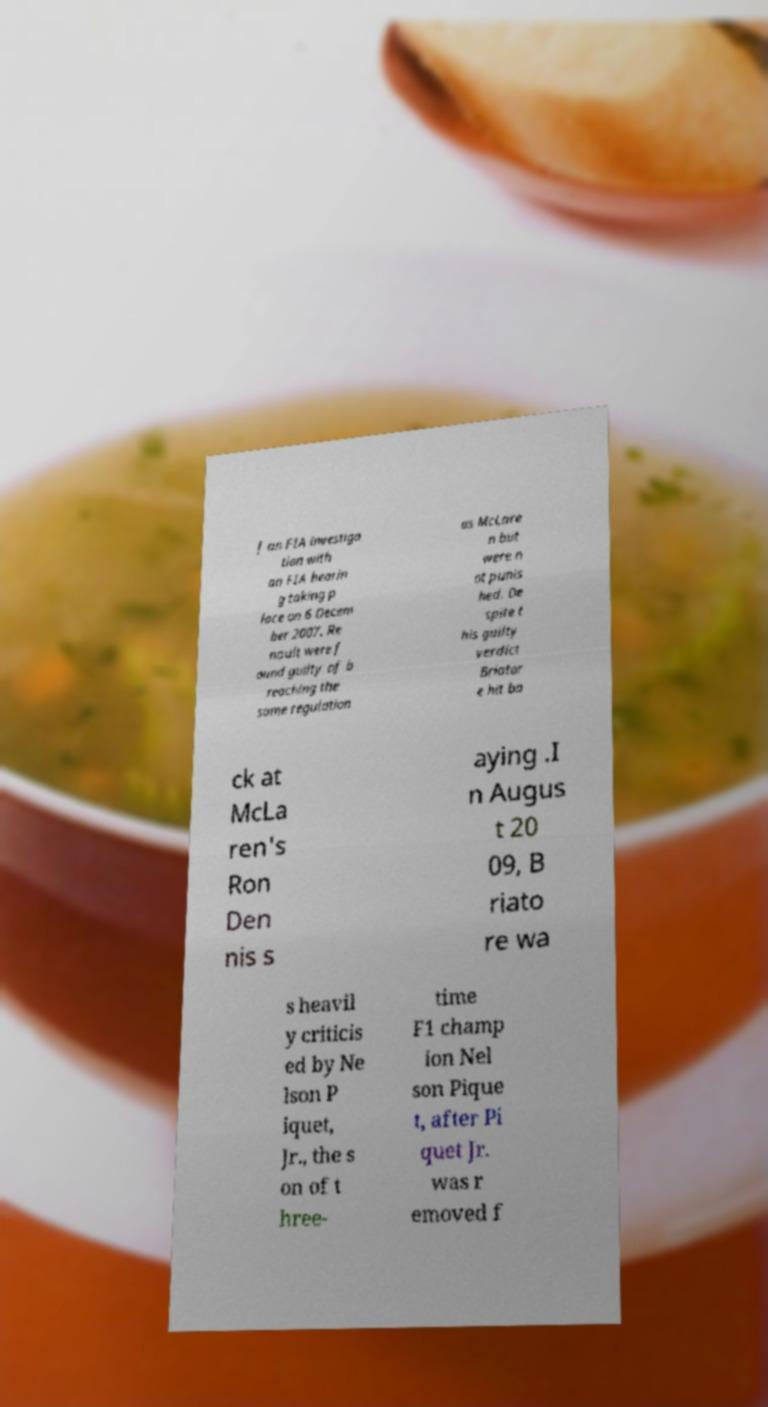Please read and relay the text visible in this image. What does it say? f an FIA investiga tion with an FIA hearin g taking p lace on 6 Decem ber 2007. Re nault were f ound guilty of b reaching the same regulation as McLare n but were n ot punis hed. De spite t his guilty verdict Briator e hit ba ck at McLa ren's Ron Den nis s aying .I n Augus t 20 09, B riato re wa s heavil y criticis ed by Ne lson P iquet, Jr., the s on of t hree- time F1 champ ion Nel son Pique t, after Pi quet Jr. was r emoved f 